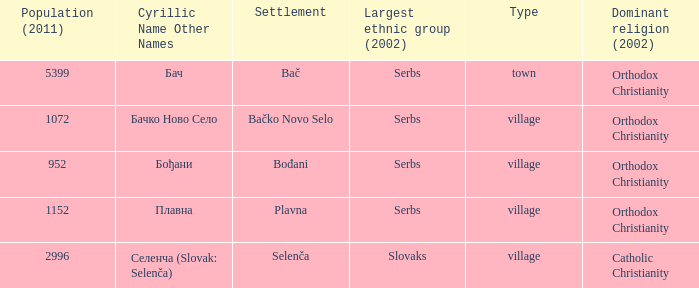What is the tiniest population listed? 952.0. 